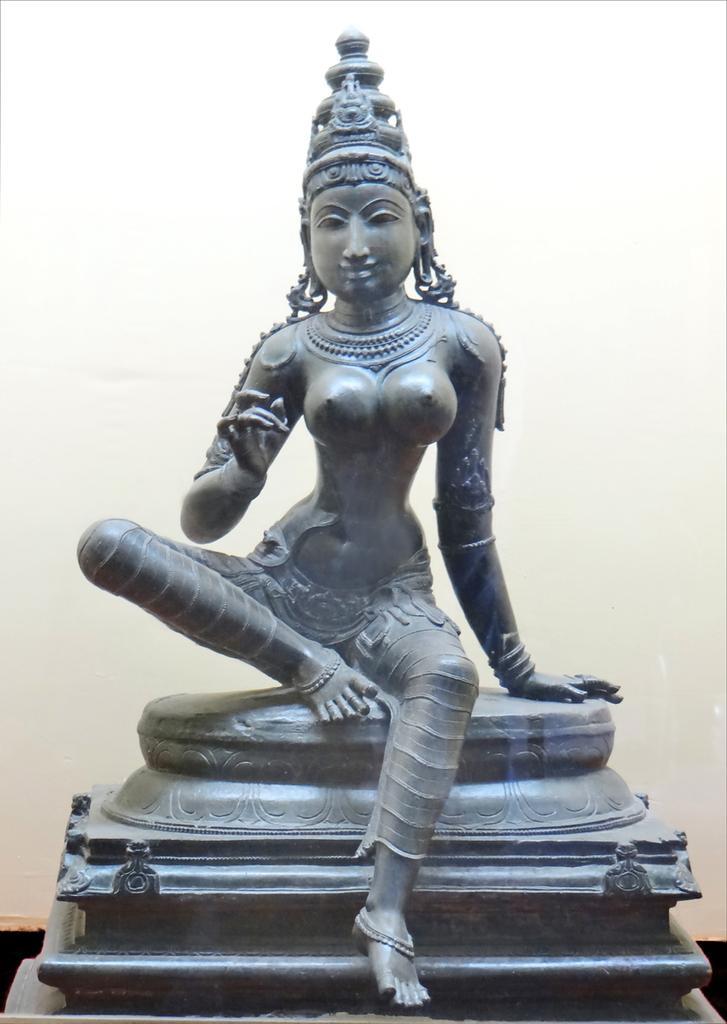Describe this image in one or two sentences. There is a sculpture on a stand. In the back it is white wall. 